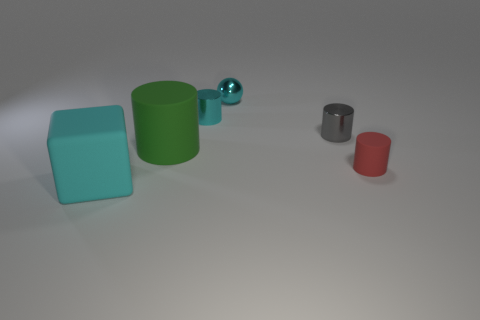Subtract all big green rubber cylinders. How many cylinders are left? 3 Subtract all cylinders. How many objects are left? 2 Subtract all gray cylinders. How many cylinders are left? 3 Subtract 4 cylinders. How many cylinders are left? 0 Add 2 large purple matte blocks. How many objects exist? 8 Subtract 0 gray balls. How many objects are left? 6 Subtract all brown cubes. Subtract all cyan spheres. How many cubes are left? 1 Subtract all blue cylinders. How many red balls are left? 0 Subtract all cyan cylinders. Subtract all small gray objects. How many objects are left? 4 Add 4 small red matte things. How many small red matte things are left? 5 